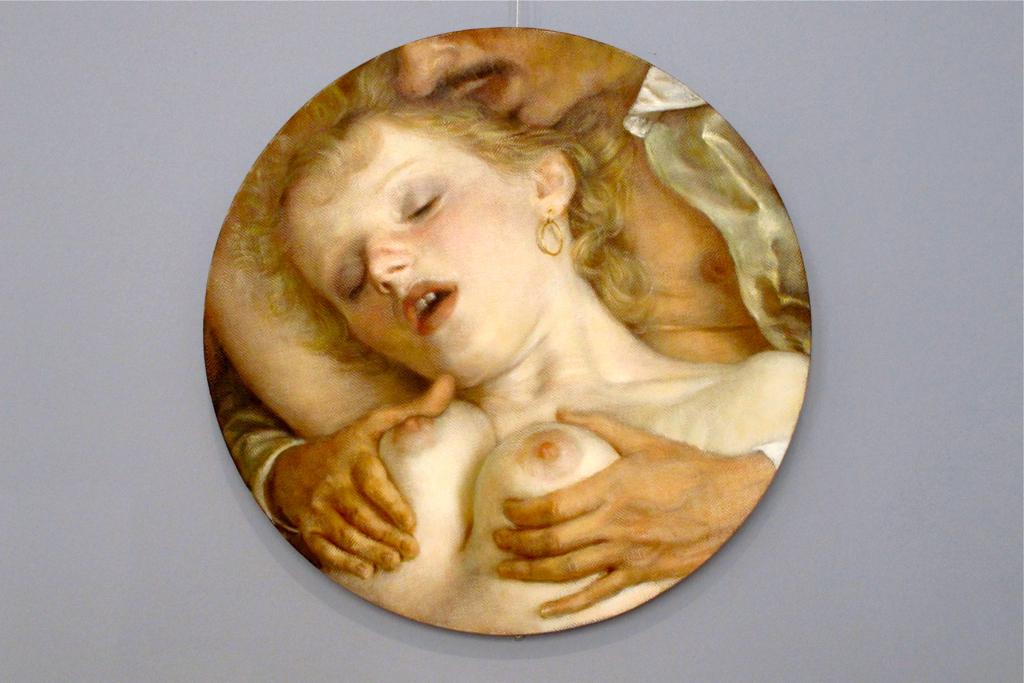What is the main object in the image? There is a frame in the image. What is depicted within the frame? The frame contains a picture of a person and a picture of a woman. Where is the frame located in the image? The frame is on the floor. What type of curtain is hanging from the frame in the image? There is no curtain present in the image; the frame contains two pictures and is located on the floor. 